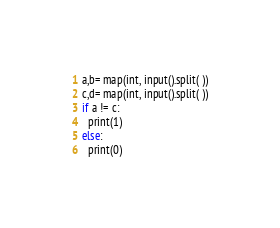<code> <loc_0><loc_0><loc_500><loc_500><_Python_>a,b= map(int, input().split( ))
c,d= map(int, input().split( ))
if a != c:
  print(1)
else:
  print(0)</code> 